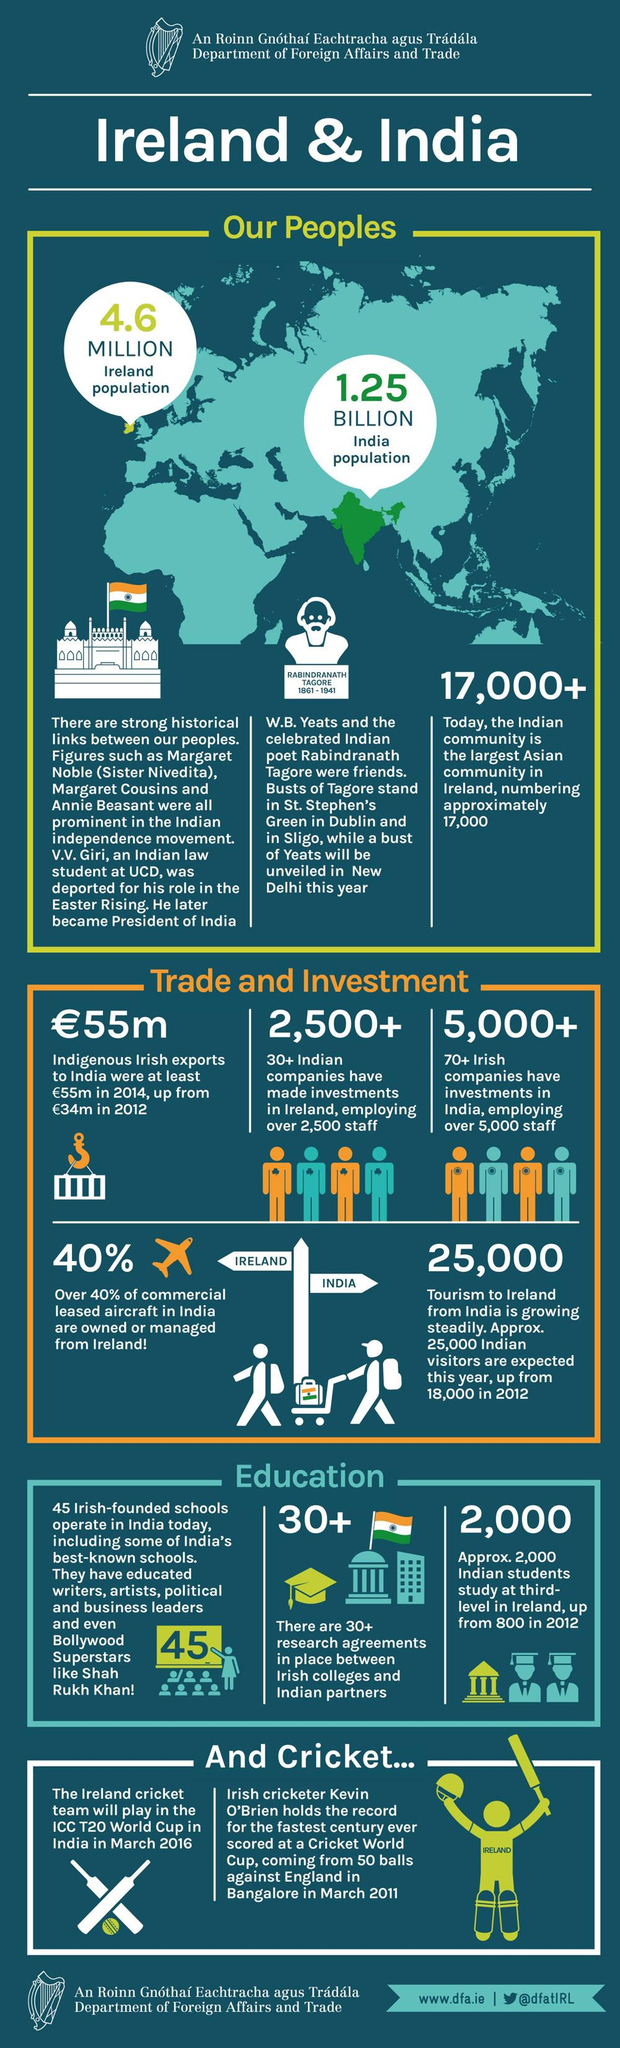Indicate a few pertinent items in this graphic. Rabindranath Tagore, an Indian poet, was a close friend of Yeats, an Irish poet. The expected number of Indian tourists this year, when compared to 2012, is projected to be approximately 7,000 more. V. V. Giri, who was involved in the Easter Rising, was deported for his role in the event. There are more than 30 research agreements between Irish colleges and Indian partners. Approximately 5,000 staff are employed by Irish companies in India. 